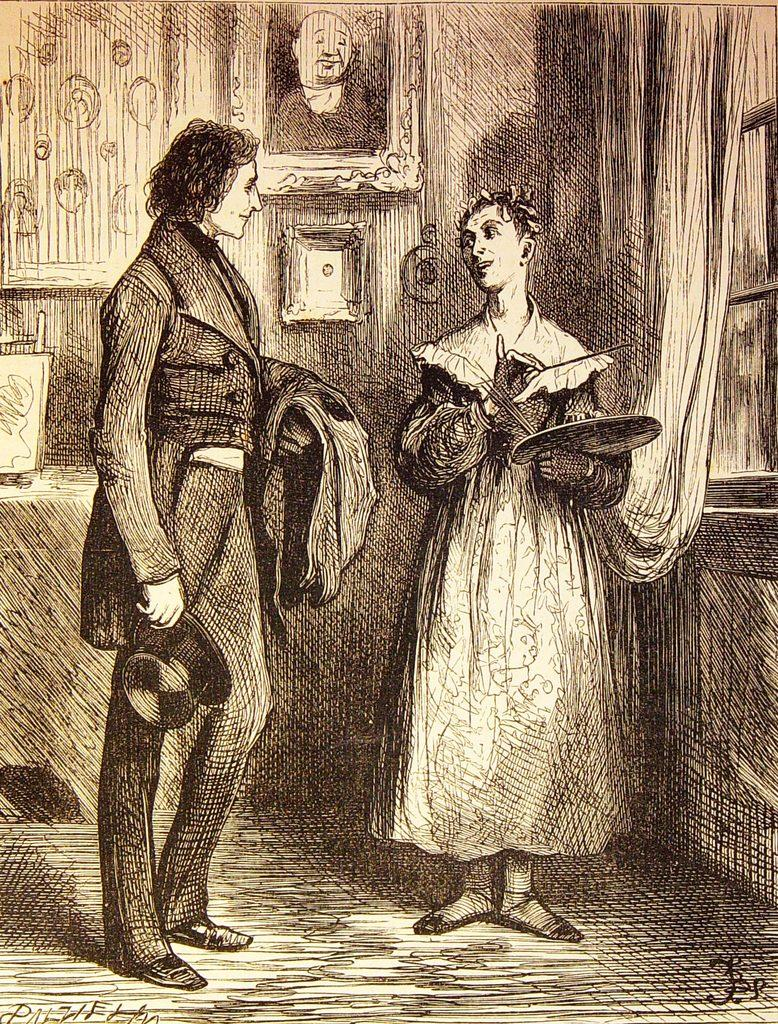How many people are present in the image? There are two people in the image. What objects can be seen in the image related to photographs? There are photo frames in the image. What type of architectural feature is visible in the image? There is a wall in the image. What type of window treatment is present in the image? There is a curtain in the image. What is the window is used for in the image? There is a window in the image. What type of flame can be seen coming from the nut in the image? There is no flame or nut present in the image. What is the sun doing in the image? The sun is not visible in the image; it is an outdoor element and not present in the scene. 